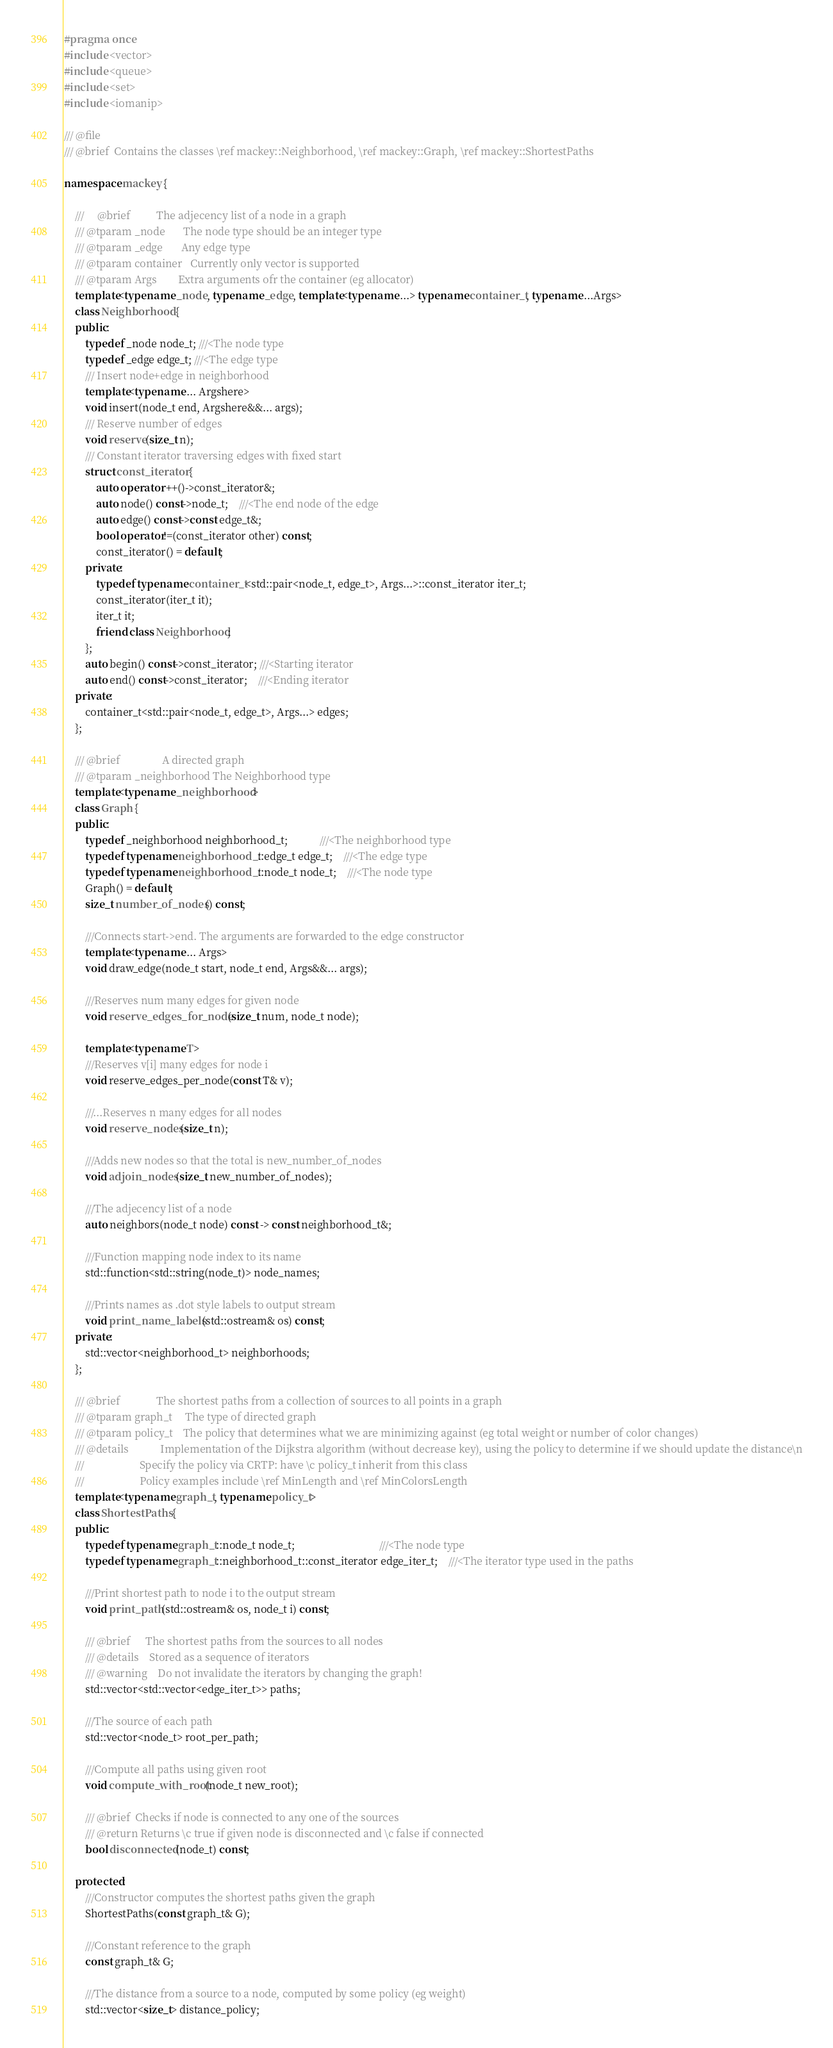Convert code to text. <code><loc_0><loc_0><loc_500><loc_500><_C++_>#pragma once
#include <vector>
#include <queue>
#include <set>
#include <iomanip> 

///	@file
///	@brief	Contains the classes \ref mackey::Neighborhood, \ref mackey::Graph, \ref mackey::ShortestPaths

namespace mackey {

	/// 	@brief			The adjecency list of a node in a graph
	///	@tparam _node 		The node type should be an integer type
	///	@tparam	_edge 		Any edge type
	///	@tparam	container	Currently only vector is supported
	///	@tparam Args		Extra arguments ofr the container (eg allocator)
	template<typename _node, typename _edge, template<typename ...> typename container_t, typename ...Args>
	class Neighborhood {
	public:
		typedef _node node_t; ///<The node type
		typedef _edge edge_t; ///<The edge type
		///	Insert node+edge in neighborhood
		template<typename ... Argshere>
		void insert(node_t end, Argshere&&... args);
		/// Reserve number of edges
		void reserve(size_t n);
		/// Constant iterator traversing edges with fixed start
		struct const_iterator {
			auto operator ++()->const_iterator&;
			auto node() const->node_t;	///<The end node of the edge
			auto edge() const->const edge_t&;
			bool operator!=(const_iterator other) const;
			const_iterator() = default;
		private:
			typedef typename container_t<std::pair<node_t, edge_t>, Args...>::const_iterator iter_t;
			const_iterator(iter_t it);
			iter_t it;
			friend class Neighborhood;
		};
		auto begin() const->const_iterator; ///<Starting iterator
		auto end() const->const_iterator;	///<Ending iterator
	private:
		container_t<std::pair<node_t, edge_t>, Args...> edges;
	};

	///	@brief				  A directed graph
	///	@tparam	_neighborhood The Neighborhood type
	template<typename _neighborhood>
	class Graph {
	public:
		typedef _neighborhood neighborhood_t; 			///<The neighborhood type
		typedef typename neighborhood_t::edge_t edge_t;	///<The edge type
		typedef typename neighborhood_t::node_t node_t;	///<The node type
		Graph() = default;
		size_t number_of_nodes() const;

		///Connects start->end. The arguments are forwarded to the edge constructor
		template<typename ... Args>
		void draw_edge(node_t start, node_t end, Args&&... args);

		///Reserves num many edges for given node
		void reserve_edges_for_node(size_t num, node_t node);

		template<typename T>
		///Reserves v[i] many edges for node i
		void reserve_edges_per_node(const T& v);

		///...Reserves n many edges for all nodes
		void reserve_nodes(size_t n);

		///Adds new nodes so that the total is new_number_of_nodes
		void adjoin_nodes(size_t new_number_of_nodes);

		///The adjecency list of a node
		auto neighbors(node_t node) const -> const neighborhood_t&;

		///Function mapping node index to its name
		std::function<std::string(node_t)> node_names;

		///Prints names as .dot style labels to output stream
		void print_name_labels(std::ostream& os) const;
	private:
		std::vector<neighborhood_t> neighborhoods;
	};
	
	/// @brief				The shortest paths from a collection of sources to all points in a graph
	/// @tparam graph_t		The type of directed graph
	/// @tparam policy_t	The policy that determines what we are minimizing against (eg total weight or number of color changes)
	/// @details			Implementation of the Dijkstra algorithm (without decrease key), using the policy to determine if we should update the distance\n
	///						Specify the policy via CRTP: have \c policy_t inherit from this class
	///						Policy examples include \ref MinLength and \ref MinColorsLength				
	template<typename graph_t, typename policy_t>
	class ShortestPaths {
	public:
		typedef typename graph_t::node_t node_t;								///<The node type
		typedef typename graph_t::neighborhood_t::const_iterator edge_iter_t;	///<The iterator type used in the paths

		///Print shortest path to node i to the output stream
		void print_path(std::ostream& os, node_t i) const;

		///	@brief		The shortest paths from the sources to all nodes 
		///	@details	Stored as a sequence of iterators
		///	@warning	Do not invalidate the iterators by changing the graph!
		std::vector<std::vector<edge_iter_t>> paths;

		///The source of each path
		std::vector<node_t> root_per_path;

		///Compute all paths using given root
		void compute_with_root(node_t new_root);

		///	@brief	Checks if node is connected to any one of the sources
		///	@return	Returns \c true if given node is disconnected and \c false if connected
		bool disconnected(node_t) const;

	protected:
		///Constructor computes the shortest paths given the graph
		ShortestPaths(const graph_t& G);

		///Constant reference to the graph
		const graph_t& G;

		///The distance from a source to a node, computed by some policy (eg weight)
		std::vector<size_t> distance_policy;
</code> 